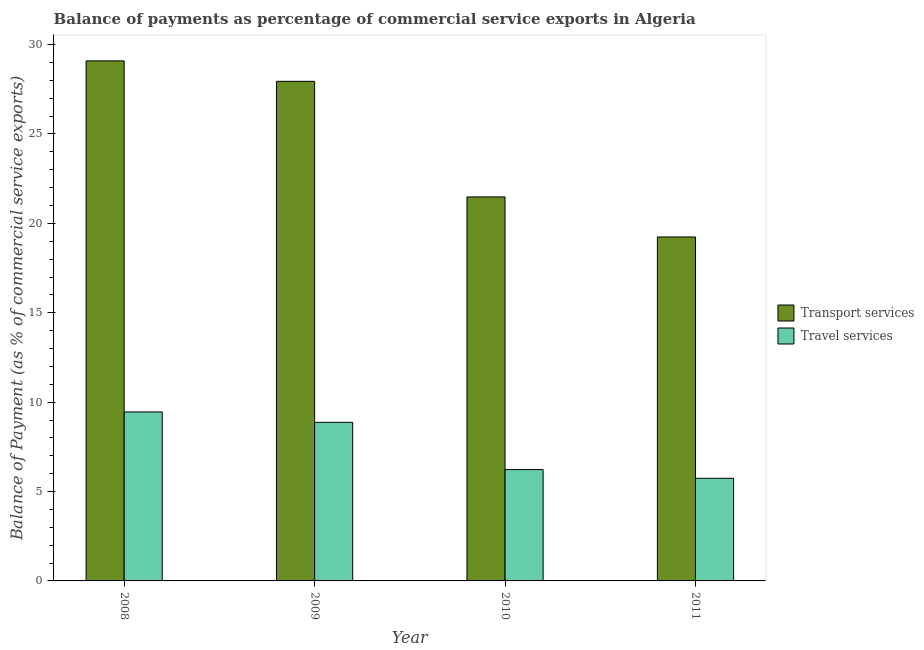How many groups of bars are there?
Your answer should be compact. 4. How many bars are there on the 1st tick from the left?
Keep it short and to the point. 2. How many bars are there on the 2nd tick from the right?
Make the answer very short. 2. In how many cases, is the number of bars for a given year not equal to the number of legend labels?
Make the answer very short. 0. What is the balance of payments of transport services in 2011?
Provide a succinct answer. 19.24. Across all years, what is the maximum balance of payments of transport services?
Your response must be concise. 29.09. Across all years, what is the minimum balance of payments of transport services?
Your response must be concise. 19.24. What is the total balance of payments of transport services in the graph?
Ensure brevity in your answer.  97.75. What is the difference between the balance of payments of travel services in 2009 and that in 2011?
Ensure brevity in your answer.  3.13. What is the difference between the balance of payments of travel services in 2008 and the balance of payments of transport services in 2010?
Offer a very short reply. 3.22. What is the average balance of payments of travel services per year?
Give a very brief answer. 7.57. In the year 2011, what is the difference between the balance of payments of transport services and balance of payments of travel services?
Your response must be concise. 0. What is the ratio of the balance of payments of travel services in 2009 to that in 2010?
Ensure brevity in your answer.  1.42. Is the balance of payments of transport services in 2008 less than that in 2011?
Make the answer very short. No. What is the difference between the highest and the second highest balance of payments of transport services?
Keep it short and to the point. 1.14. What is the difference between the highest and the lowest balance of payments of travel services?
Your answer should be compact. 3.71. What does the 2nd bar from the left in 2009 represents?
Give a very brief answer. Travel services. What does the 2nd bar from the right in 2010 represents?
Your answer should be compact. Transport services. How many bars are there?
Keep it short and to the point. 8. Are all the bars in the graph horizontal?
Your answer should be very brief. No. How many years are there in the graph?
Your response must be concise. 4. Does the graph contain any zero values?
Keep it short and to the point. No. How many legend labels are there?
Give a very brief answer. 2. What is the title of the graph?
Your answer should be very brief. Balance of payments as percentage of commercial service exports in Algeria. What is the label or title of the Y-axis?
Give a very brief answer. Balance of Payment (as % of commercial service exports). What is the Balance of Payment (as % of commercial service exports) in Transport services in 2008?
Your response must be concise. 29.09. What is the Balance of Payment (as % of commercial service exports) of Travel services in 2008?
Make the answer very short. 9.45. What is the Balance of Payment (as % of commercial service exports) of Transport services in 2009?
Make the answer very short. 27.95. What is the Balance of Payment (as % of commercial service exports) in Travel services in 2009?
Provide a succinct answer. 8.87. What is the Balance of Payment (as % of commercial service exports) in Transport services in 2010?
Keep it short and to the point. 21.48. What is the Balance of Payment (as % of commercial service exports) of Travel services in 2010?
Offer a very short reply. 6.23. What is the Balance of Payment (as % of commercial service exports) of Transport services in 2011?
Provide a short and direct response. 19.24. What is the Balance of Payment (as % of commercial service exports) of Travel services in 2011?
Your response must be concise. 5.74. Across all years, what is the maximum Balance of Payment (as % of commercial service exports) in Transport services?
Your answer should be compact. 29.09. Across all years, what is the maximum Balance of Payment (as % of commercial service exports) in Travel services?
Provide a short and direct response. 9.45. Across all years, what is the minimum Balance of Payment (as % of commercial service exports) of Transport services?
Give a very brief answer. 19.24. Across all years, what is the minimum Balance of Payment (as % of commercial service exports) of Travel services?
Offer a very short reply. 5.74. What is the total Balance of Payment (as % of commercial service exports) of Transport services in the graph?
Give a very brief answer. 97.75. What is the total Balance of Payment (as % of commercial service exports) of Travel services in the graph?
Your response must be concise. 30.29. What is the difference between the Balance of Payment (as % of commercial service exports) in Transport services in 2008 and that in 2009?
Make the answer very short. 1.14. What is the difference between the Balance of Payment (as % of commercial service exports) of Travel services in 2008 and that in 2009?
Offer a terse response. 0.58. What is the difference between the Balance of Payment (as % of commercial service exports) of Transport services in 2008 and that in 2010?
Give a very brief answer. 7.61. What is the difference between the Balance of Payment (as % of commercial service exports) in Travel services in 2008 and that in 2010?
Make the answer very short. 3.22. What is the difference between the Balance of Payment (as % of commercial service exports) in Transport services in 2008 and that in 2011?
Provide a short and direct response. 9.85. What is the difference between the Balance of Payment (as % of commercial service exports) of Travel services in 2008 and that in 2011?
Provide a short and direct response. 3.71. What is the difference between the Balance of Payment (as % of commercial service exports) of Transport services in 2009 and that in 2010?
Your answer should be very brief. 6.47. What is the difference between the Balance of Payment (as % of commercial service exports) of Travel services in 2009 and that in 2010?
Keep it short and to the point. 2.64. What is the difference between the Balance of Payment (as % of commercial service exports) in Transport services in 2009 and that in 2011?
Offer a terse response. 8.71. What is the difference between the Balance of Payment (as % of commercial service exports) in Travel services in 2009 and that in 2011?
Provide a short and direct response. 3.13. What is the difference between the Balance of Payment (as % of commercial service exports) of Transport services in 2010 and that in 2011?
Ensure brevity in your answer.  2.24. What is the difference between the Balance of Payment (as % of commercial service exports) of Travel services in 2010 and that in 2011?
Provide a short and direct response. 0.49. What is the difference between the Balance of Payment (as % of commercial service exports) in Transport services in 2008 and the Balance of Payment (as % of commercial service exports) in Travel services in 2009?
Make the answer very short. 20.22. What is the difference between the Balance of Payment (as % of commercial service exports) of Transport services in 2008 and the Balance of Payment (as % of commercial service exports) of Travel services in 2010?
Make the answer very short. 22.86. What is the difference between the Balance of Payment (as % of commercial service exports) in Transport services in 2008 and the Balance of Payment (as % of commercial service exports) in Travel services in 2011?
Your response must be concise. 23.35. What is the difference between the Balance of Payment (as % of commercial service exports) of Transport services in 2009 and the Balance of Payment (as % of commercial service exports) of Travel services in 2010?
Your answer should be very brief. 21.72. What is the difference between the Balance of Payment (as % of commercial service exports) of Transport services in 2009 and the Balance of Payment (as % of commercial service exports) of Travel services in 2011?
Offer a terse response. 22.2. What is the difference between the Balance of Payment (as % of commercial service exports) of Transport services in 2010 and the Balance of Payment (as % of commercial service exports) of Travel services in 2011?
Your answer should be compact. 15.74. What is the average Balance of Payment (as % of commercial service exports) in Transport services per year?
Offer a terse response. 24.44. What is the average Balance of Payment (as % of commercial service exports) in Travel services per year?
Offer a terse response. 7.57. In the year 2008, what is the difference between the Balance of Payment (as % of commercial service exports) of Transport services and Balance of Payment (as % of commercial service exports) of Travel services?
Offer a terse response. 19.64. In the year 2009, what is the difference between the Balance of Payment (as % of commercial service exports) of Transport services and Balance of Payment (as % of commercial service exports) of Travel services?
Your response must be concise. 19.08. In the year 2010, what is the difference between the Balance of Payment (as % of commercial service exports) of Transport services and Balance of Payment (as % of commercial service exports) of Travel services?
Make the answer very short. 15.25. In the year 2011, what is the difference between the Balance of Payment (as % of commercial service exports) in Transport services and Balance of Payment (as % of commercial service exports) in Travel services?
Offer a very short reply. 13.5. What is the ratio of the Balance of Payment (as % of commercial service exports) in Transport services in 2008 to that in 2009?
Keep it short and to the point. 1.04. What is the ratio of the Balance of Payment (as % of commercial service exports) of Travel services in 2008 to that in 2009?
Your response must be concise. 1.07. What is the ratio of the Balance of Payment (as % of commercial service exports) in Transport services in 2008 to that in 2010?
Provide a short and direct response. 1.35. What is the ratio of the Balance of Payment (as % of commercial service exports) in Travel services in 2008 to that in 2010?
Keep it short and to the point. 1.52. What is the ratio of the Balance of Payment (as % of commercial service exports) of Transport services in 2008 to that in 2011?
Offer a very short reply. 1.51. What is the ratio of the Balance of Payment (as % of commercial service exports) in Travel services in 2008 to that in 2011?
Your answer should be very brief. 1.65. What is the ratio of the Balance of Payment (as % of commercial service exports) of Transport services in 2009 to that in 2010?
Your response must be concise. 1.3. What is the ratio of the Balance of Payment (as % of commercial service exports) in Travel services in 2009 to that in 2010?
Provide a short and direct response. 1.42. What is the ratio of the Balance of Payment (as % of commercial service exports) in Transport services in 2009 to that in 2011?
Ensure brevity in your answer.  1.45. What is the ratio of the Balance of Payment (as % of commercial service exports) of Travel services in 2009 to that in 2011?
Keep it short and to the point. 1.54. What is the ratio of the Balance of Payment (as % of commercial service exports) in Transport services in 2010 to that in 2011?
Provide a succinct answer. 1.12. What is the ratio of the Balance of Payment (as % of commercial service exports) in Travel services in 2010 to that in 2011?
Provide a succinct answer. 1.08. What is the difference between the highest and the second highest Balance of Payment (as % of commercial service exports) of Transport services?
Your response must be concise. 1.14. What is the difference between the highest and the second highest Balance of Payment (as % of commercial service exports) in Travel services?
Ensure brevity in your answer.  0.58. What is the difference between the highest and the lowest Balance of Payment (as % of commercial service exports) in Transport services?
Keep it short and to the point. 9.85. What is the difference between the highest and the lowest Balance of Payment (as % of commercial service exports) in Travel services?
Offer a very short reply. 3.71. 